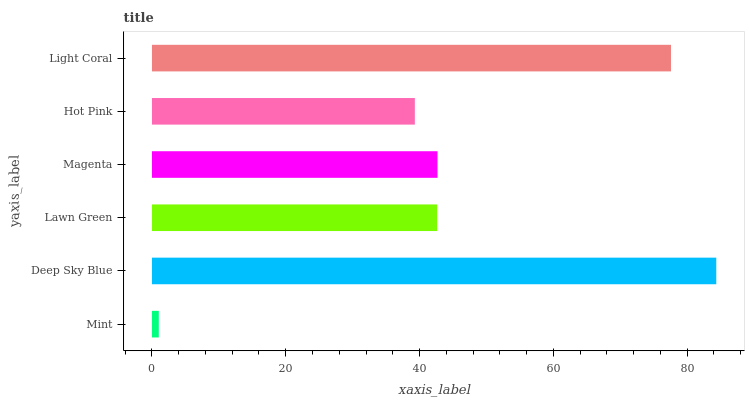Is Mint the minimum?
Answer yes or no. Yes. Is Deep Sky Blue the maximum?
Answer yes or no. Yes. Is Lawn Green the minimum?
Answer yes or no. No. Is Lawn Green the maximum?
Answer yes or no. No. Is Deep Sky Blue greater than Lawn Green?
Answer yes or no. Yes. Is Lawn Green less than Deep Sky Blue?
Answer yes or no. Yes. Is Lawn Green greater than Deep Sky Blue?
Answer yes or no. No. Is Deep Sky Blue less than Lawn Green?
Answer yes or no. No. Is Magenta the high median?
Answer yes or no. Yes. Is Lawn Green the low median?
Answer yes or no. Yes. Is Hot Pink the high median?
Answer yes or no. No. Is Magenta the low median?
Answer yes or no. No. 